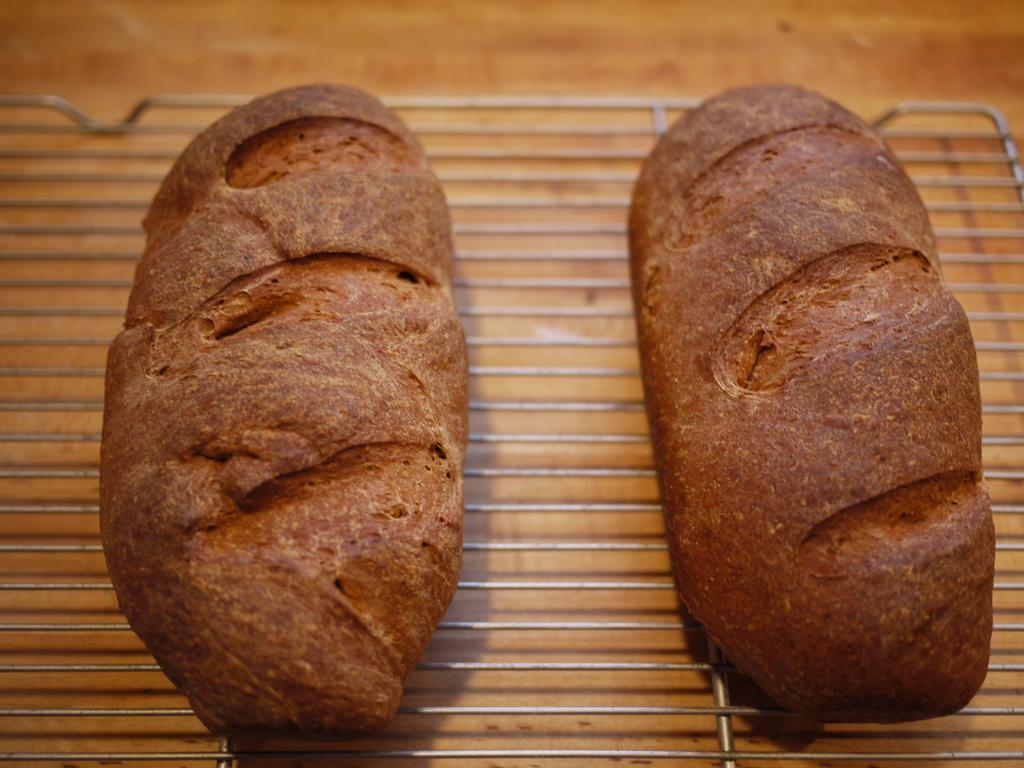What can be seen in the foreground of the image? There are two objects in the foreground of the image. What is the color of the objects in the foreground? The objects are brown in color. What type of apparel is being worn by the lead object in the image? There is no apparel present in the image, as the objects are not living beings. 